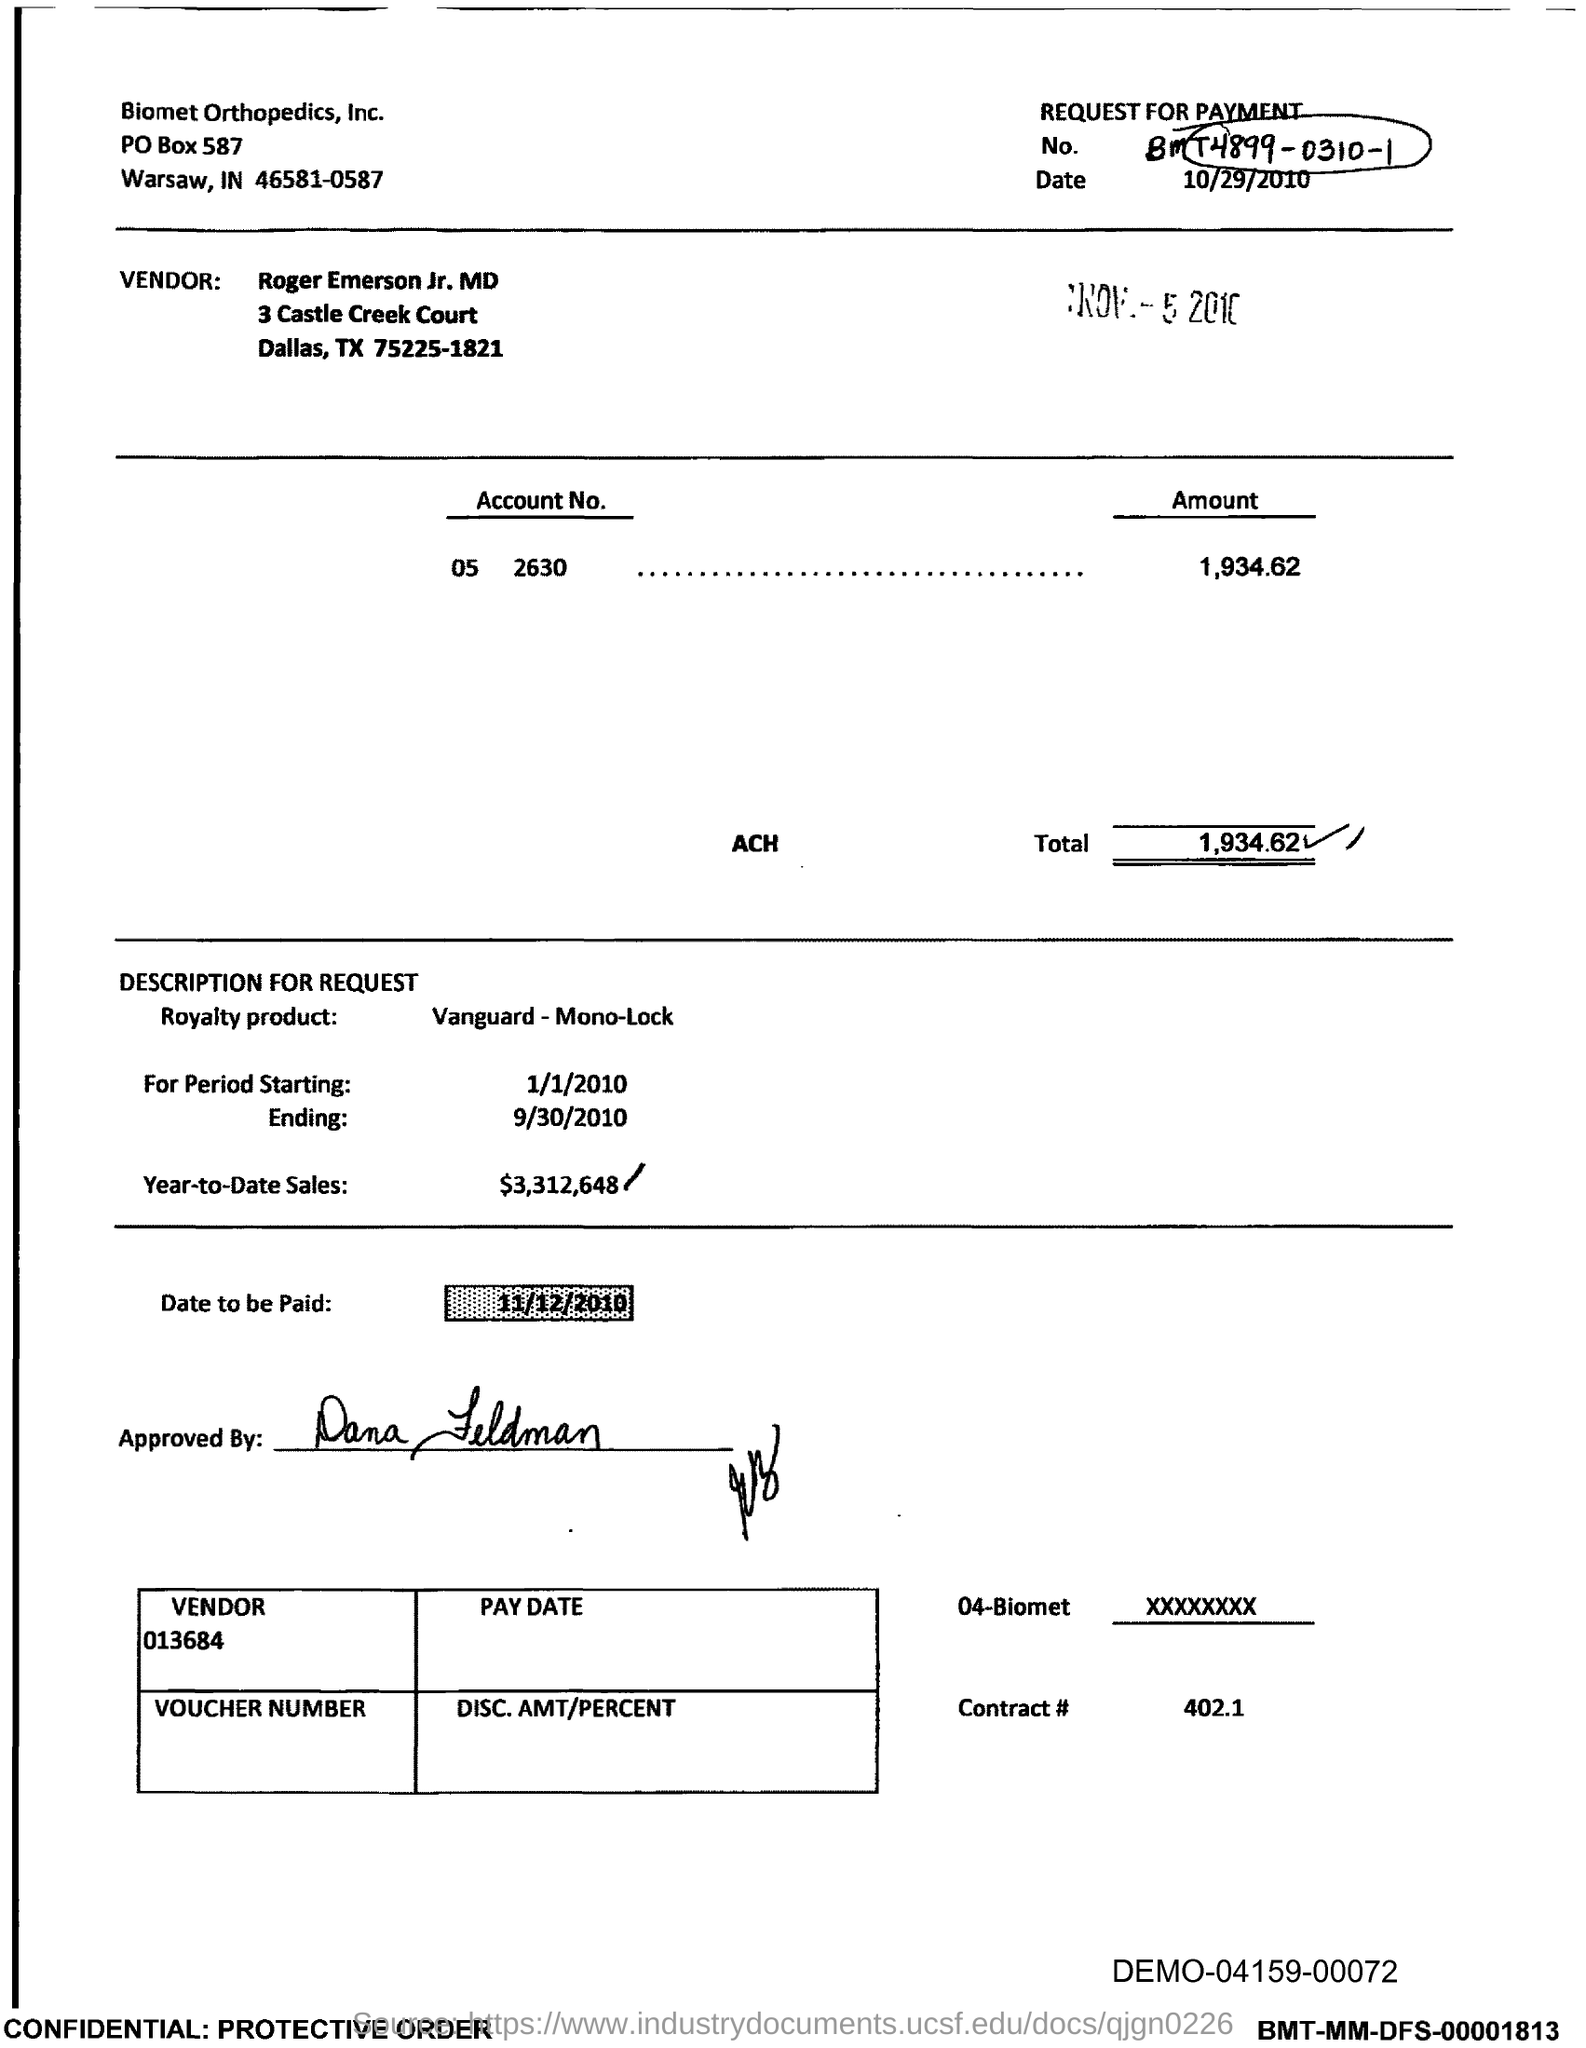What is the request for payment No. given in the document?
Your answer should be very brief. BMT4899-0310-1. Who is the Vendor mentioned in the document?
Ensure brevity in your answer.  Roger emerson jr. md. What is the Account No. given in the document?
Offer a terse response. 05 2630. What is the total amount to be paid given in the document?
Offer a very short reply. 1,934 62. What is the royalty product mentioned in the document?
Provide a short and direct response. Vanguard-Mono-Lock. What is the Year-to-Date Sales of the royalty product?
Provide a short and direct response. $3,312,648. What is the vendor no given in the document?
Provide a succinct answer. 013684. What is the contract # given in the document?
Give a very brief answer. 402.1. Which company is mentioned in the header of the document?
Give a very brief answer. Biomet Orthopedics, Inc. 